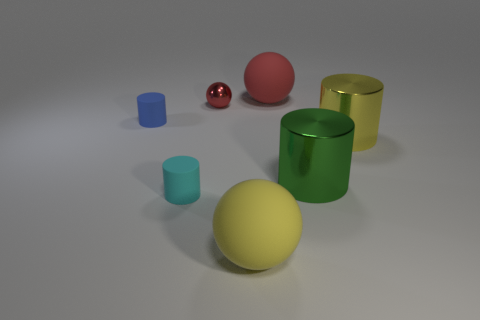Add 1 tiny brown things. How many objects exist? 8 Subtract all cylinders. How many objects are left? 3 Subtract all big yellow metallic cylinders. Subtract all green objects. How many objects are left? 5 Add 5 yellow metallic cylinders. How many yellow metallic cylinders are left? 6 Add 7 green blocks. How many green blocks exist? 7 Subtract 0 blue spheres. How many objects are left? 7 